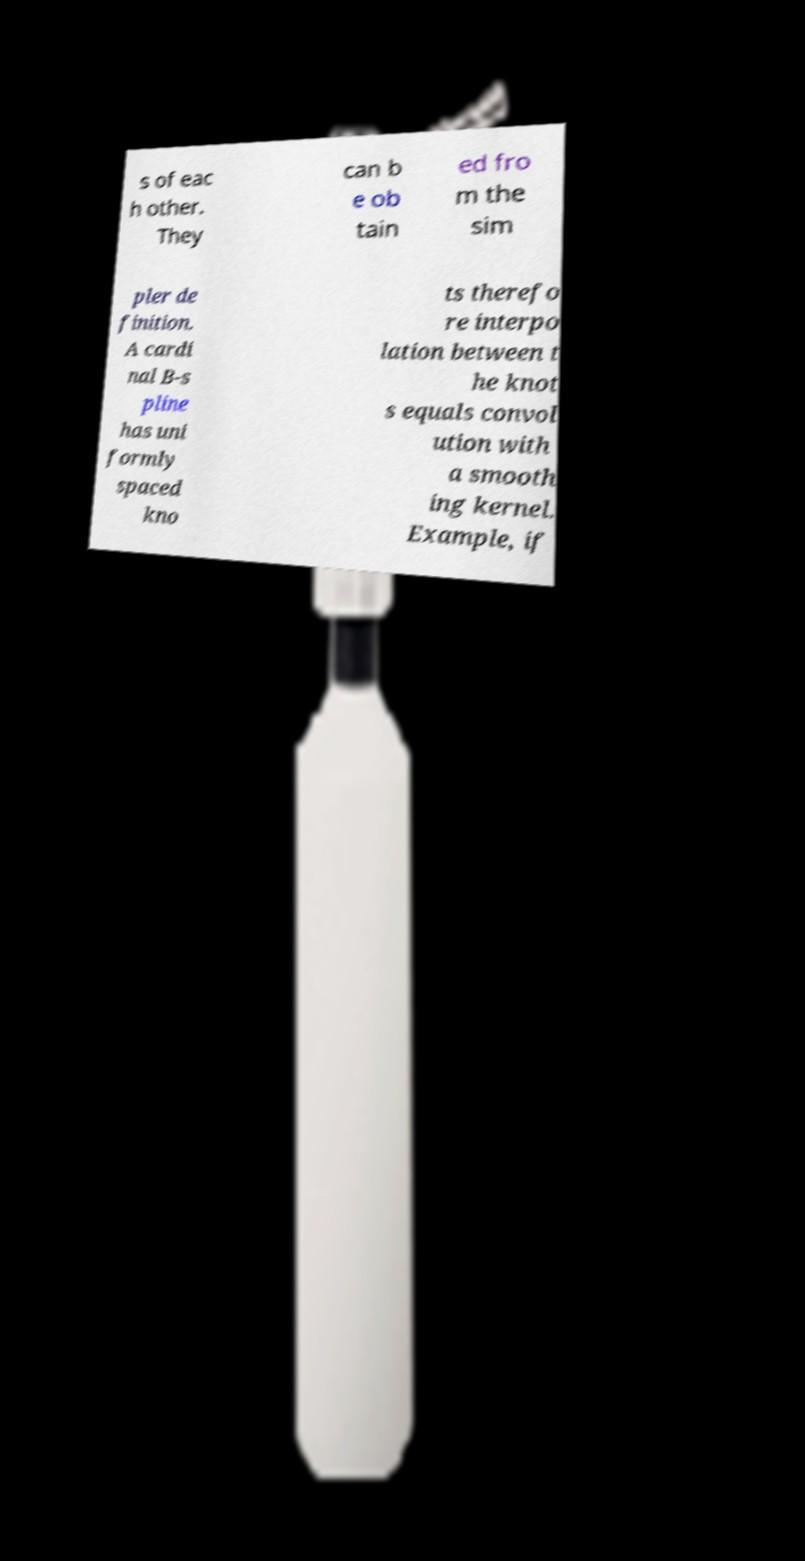Please read and relay the text visible in this image. What does it say? s of eac h other. They can b e ob tain ed fro m the sim pler de finition. A cardi nal B-s pline has uni formly spaced kno ts therefo re interpo lation between t he knot s equals convol ution with a smooth ing kernel. Example, if 